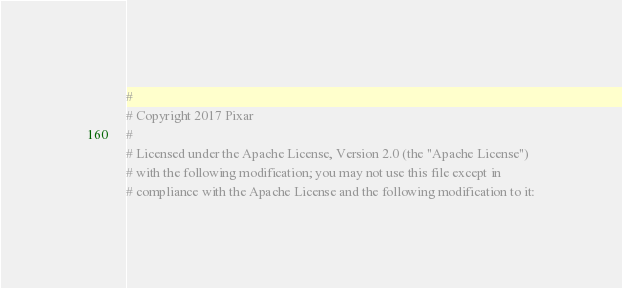<code> <loc_0><loc_0><loc_500><loc_500><_Python_>#
# Copyright 2017 Pixar
#
# Licensed under the Apache License, Version 2.0 (the "Apache License")
# with the following modification; you may not use this file except in
# compliance with the Apache License and the following modification to it:</code> 